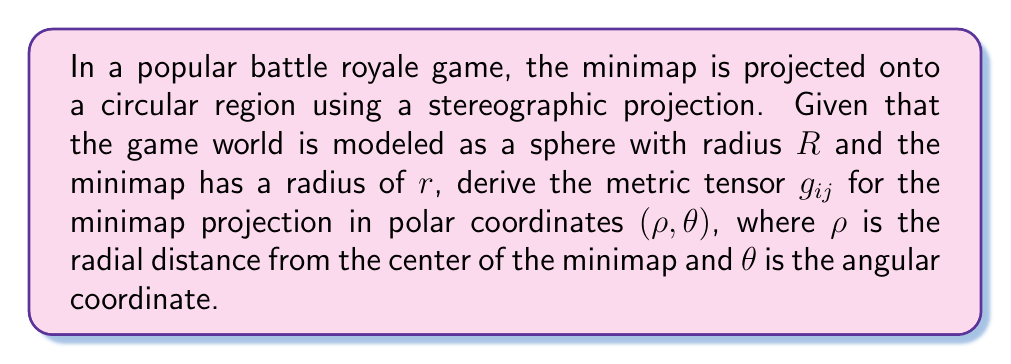Can you solve this math problem? Let's approach this step-by-step:

1) The stereographic projection maps a sphere of radius $R$ onto a plane. The relationship between the sphere coordinates $(R,χ,φ)$ and the plane coordinates $(ρ,θ)$ is:

   $$ρ = \frac{2Rr}{R+R\cos χ}, \quad θ = φ$$

2) The metric tensor on the sphere in $(χ,φ)$ coordinates is:

   $$ds^2 = R^2(dχ^2 + \sin^2χ dφ^2)$$

3) We need to express $dχ$ and $dφ$ in terms of $dρ$ and $dθ$. From the projection formula:

   $$\frac{dρ}{dχ} = \frac{2Rr\sin χ}{(R+R\cos χ)^2}$$

4) Inverting this:

   $$dχ = \frac{(R+R\cos χ)^2}{2Rr\sin χ}dρ = \frac{4R^2}{ρ(4R^2-ρ^2)}dρ$$

5) Also, $dφ = dθ$

6) Substituting these into the sphere metric:

   $$ds^2 = R^2(\frac{4R^2}{ρ^2(4R^2-ρ^2)^2}dρ^2 + \sin^2χ dθ^2)$$

7) We need to express $\sin^2χ$ in terms of $ρ$. From the projection formula:

   $$\sin^2χ = \frac{4R^2ρ^2}{(4R^2+ρ^2)^2}$$

8) Substituting this in:

   $$ds^2 = \frac{16R^4}{ρ^2(4R^2-ρ^2)^2}dρ^2 + \frac{4R^2ρ^2}{(4R^2+ρ^2)^2}dθ^2$$

9) Therefore, the metric tensor $g_{ij}$ in $(ρ,θ)$ coordinates is:

   $$g_{ij} = \begin{pmatrix}
   \frac{16R^4}{ρ^2(4R^2-ρ^2)^2} & 0 \\
   0 & \frac{4R^2ρ^2}{(4R^2+ρ^2)^2}
   \end{pmatrix}$$
Answer: $$g_{ij} = \begin{pmatrix}
\frac{16R^4}{ρ^2(4R^2-ρ^2)^2} & 0 \\
0 & \frac{4R^2ρ^2}{(4R^2+ρ^2)^2}
\end{pmatrix}$$ 